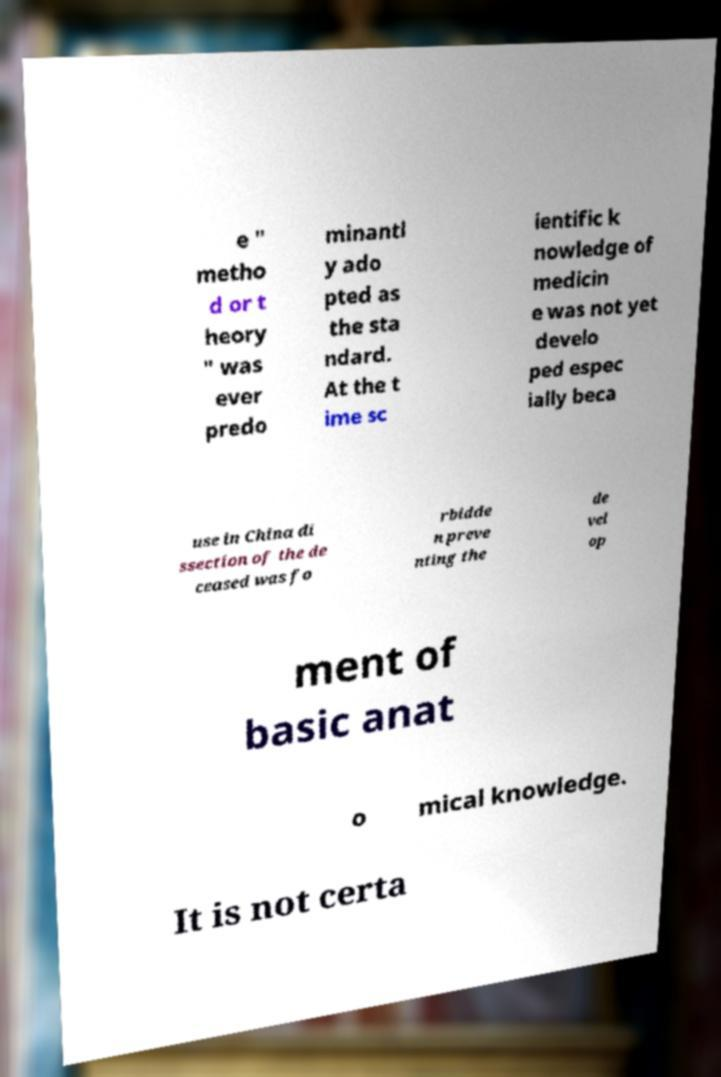Could you assist in decoding the text presented in this image and type it out clearly? e " metho d or t heory " was ever predo minantl y ado pted as the sta ndard. At the t ime sc ientific k nowledge of medicin e was not yet develo ped espec ially beca use in China di ssection of the de ceased was fo rbidde n preve nting the de vel op ment of basic anat o mical knowledge. It is not certa 